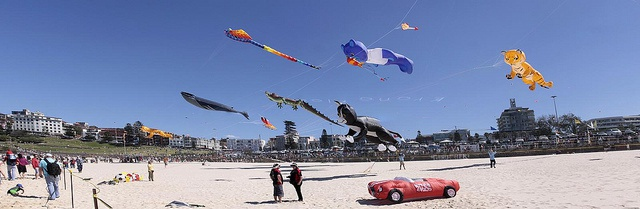Describe the objects in this image and their specific colors. I can see people in blue, gray, black, darkgray, and lightgray tones, car in blue, brown, black, and lightpink tones, kite in blue, black, darkgray, gray, and lavender tones, kite in blue, darkblue, and lavender tones, and kite in blue, lightgray, tan, darkgray, and gray tones in this image. 